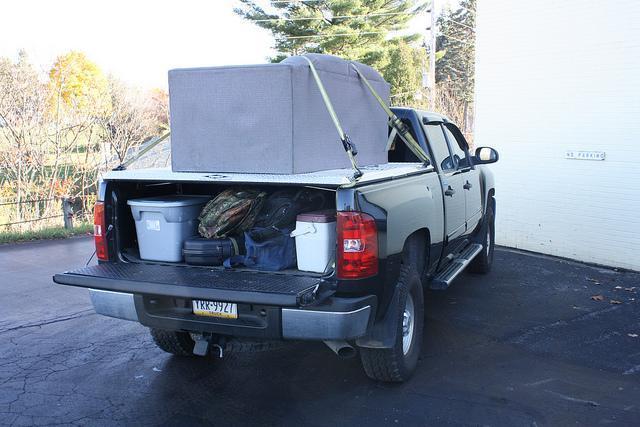How many backpacks can be seen?
Give a very brief answer. 2. How many bears are there?
Give a very brief answer. 0. 